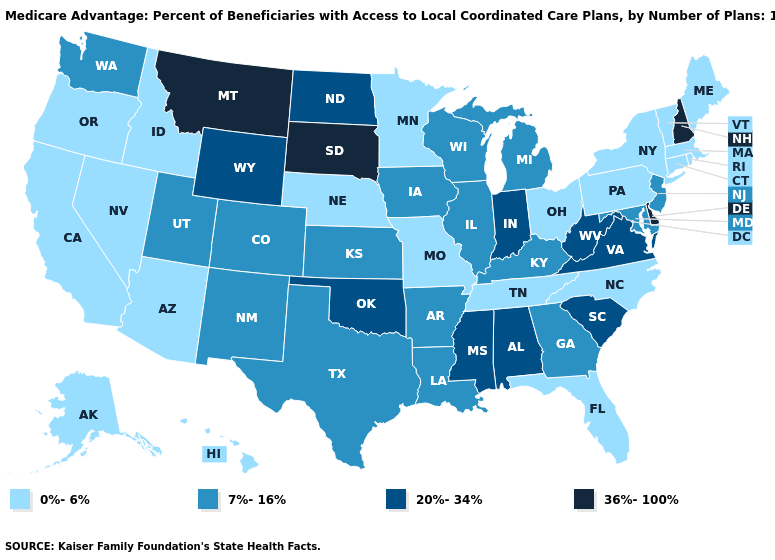What is the value of New Mexico?
Give a very brief answer. 7%-16%. Name the states that have a value in the range 0%-6%?
Answer briefly. Alaska, Arizona, California, Connecticut, Florida, Hawaii, Idaho, Massachusetts, Maine, Minnesota, Missouri, North Carolina, Nebraska, Nevada, New York, Ohio, Oregon, Pennsylvania, Rhode Island, Tennessee, Vermont. Name the states that have a value in the range 0%-6%?
Be succinct. Alaska, Arizona, California, Connecticut, Florida, Hawaii, Idaho, Massachusetts, Maine, Minnesota, Missouri, North Carolina, Nebraska, Nevada, New York, Ohio, Oregon, Pennsylvania, Rhode Island, Tennessee, Vermont. Which states hav the highest value in the West?
Give a very brief answer. Montana. Which states have the lowest value in the USA?
Be succinct. Alaska, Arizona, California, Connecticut, Florida, Hawaii, Idaho, Massachusetts, Maine, Minnesota, Missouri, North Carolina, Nebraska, Nevada, New York, Ohio, Oregon, Pennsylvania, Rhode Island, Tennessee, Vermont. Name the states that have a value in the range 0%-6%?
Write a very short answer. Alaska, Arizona, California, Connecticut, Florida, Hawaii, Idaho, Massachusetts, Maine, Minnesota, Missouri, North Carolina, Nebraska, Nevada, New York, Ohio, Oregon, Pennsylvania, Rhode Island, Tennessee, Vermont. What is the lowest value in the MidWest?
Keep it brief. 0%-6%. Among the states that border Iowa , does South Dakota have the highest value?
Short answer required. Yes. Which states have the lowest value in the West?
Write a very short answer. Alaska, Arizona, California, Hawaii, Idaho, Nevada, Oregon. Name the states that have a value in the range 7%-16%?
Concise answer only. Arkansas, Colorado, Georgia, Iowa, Illinois, Kansas, Kentucky, Louisiana, Maryland, Michigan, New Jersey, New Mexico, Texas, Utah, Washington, Wisconsin. Name the states that have a value in the range 0%-6%?
Be succinct. Alaska, Arizona, California, Connecticut, Florida, Hawaii, Idaho, Massachusetts, Maine, Minnesota, Missouri, North Carolina, Nebraska, Nevada, New York, Ohio, Oregon, Pennsylvania, Rhode Island, Tennessee, Vermont. Name the states that have a value in the range 36%-100%?
Write a very short answer. Delaware, Montana, New Hampshire, South Dakota. What is the lowest value in the USA?
Write a very short answer. 0%-6%. Among the states that border Nebraska , does South Dakota have the highest value?
Short answer required. Yes. What is the highest value in the West ?
Quick response, please. 36%-100%. 